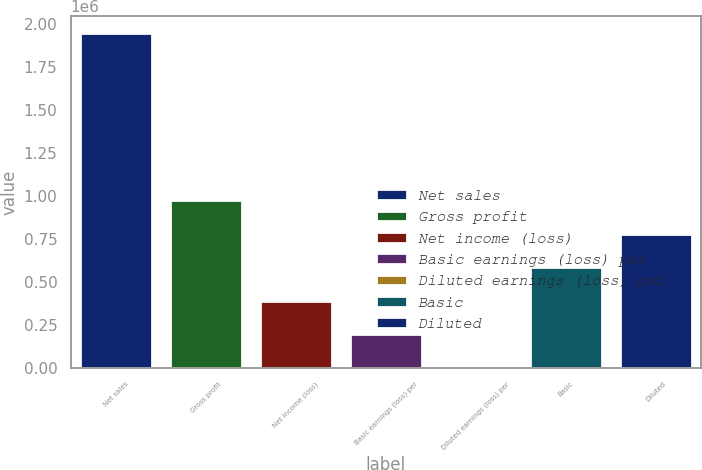Convert chart. <chart><loc_0><loc_0><loc_500><loc_500><bar_chart><fcel>Net sales<fcel>Gross profit<fcel>Net income (loss)<fcel>Basic earnings (loss) per<fcel>Diluted earnings (loss) per<fcel>Basic<fcel>Diluted<nl><fcel>1.94577e+06<fcel>972886<fcel>389155<fcel>194577<fcel>0.17<fcel>583732<fcel>778309<nl></chart> 